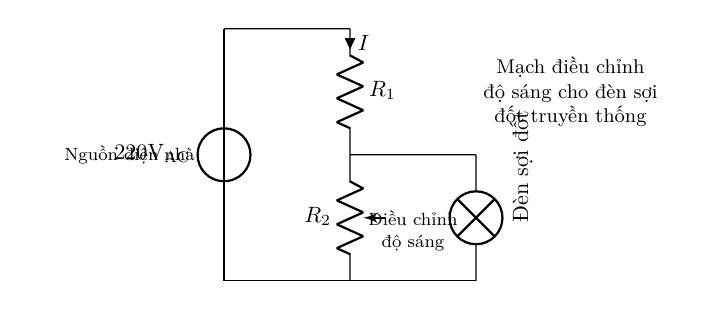What is the main power source for this circuit? The main power source is a 220V AC voltage supply, indicated by the voltage source label in the circuit.
Answer: 220V AC What type of component is used to adjust the brightness of the lamp? A potentiometer is used to adjust the brightness, as shown in the circuit diagram where it is labeled as R2.
Answer: Potentiometer What is R1 in the circuit? R1 is identified as a resistor in the circuit diagram. It is used in conjunction with the potentiometer to form a voltage divider for the lamp.
Answer: Resistor How does the brightness change when adjusting R2? Adjusting R2 changes the resistance value, which alters the voltage across the lamp, thus changing its brightness. As R2 increases, the lamp dims, and as R2 decreases, the lamp brightens.
Answer: Changes brightness What is the purpose of the voltage divider in this circuit? The voltage divider, formed by R1 and R2, reduces the voltage supplied to the lamp, allowing for brightness control. This is achieved by distributing the voltage between the two resistors according to their resistances.
Answer: Brightness control What does the current I signify in this circuit? The current I represents the flow of electric charge through the circuit components, which is critical for determining how much voltage drop occurs across each component, particularly across the lamp.
Answer: Electric current 